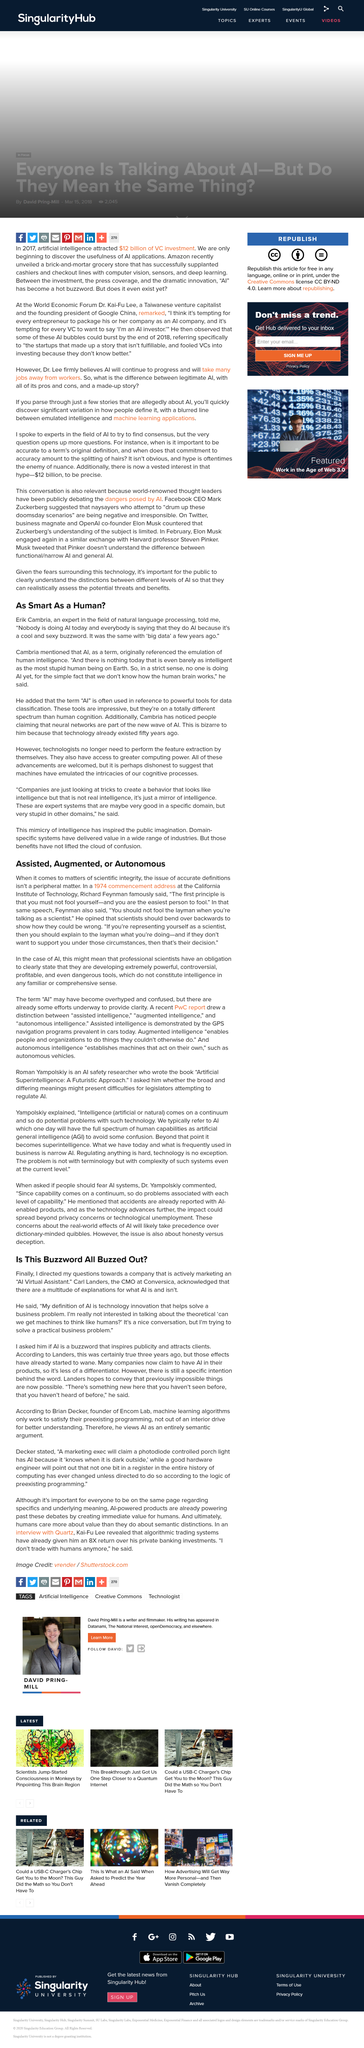Give some essential details in this illustration. AI virtual assistants do not think like humans, as the concept of artificial intelligence replicating human-like thought processes is purely theoretical and has yet to be achieved. Scientists, as per the advice of Richard Feynman, should strive to demonstrate their willingness to be incorrect by bending over backwards to consider alternative perspectives and hypothesis. According to Erik Cambria, AI is not smarter than the most stupid human being on earth. Our AI virtual assistant strives to solve practical business problems by providing efficient and effective solutions that enhance productivity and streamline operations. Richard Feynman asserts that you, the reader, are the easiest person to fool. 